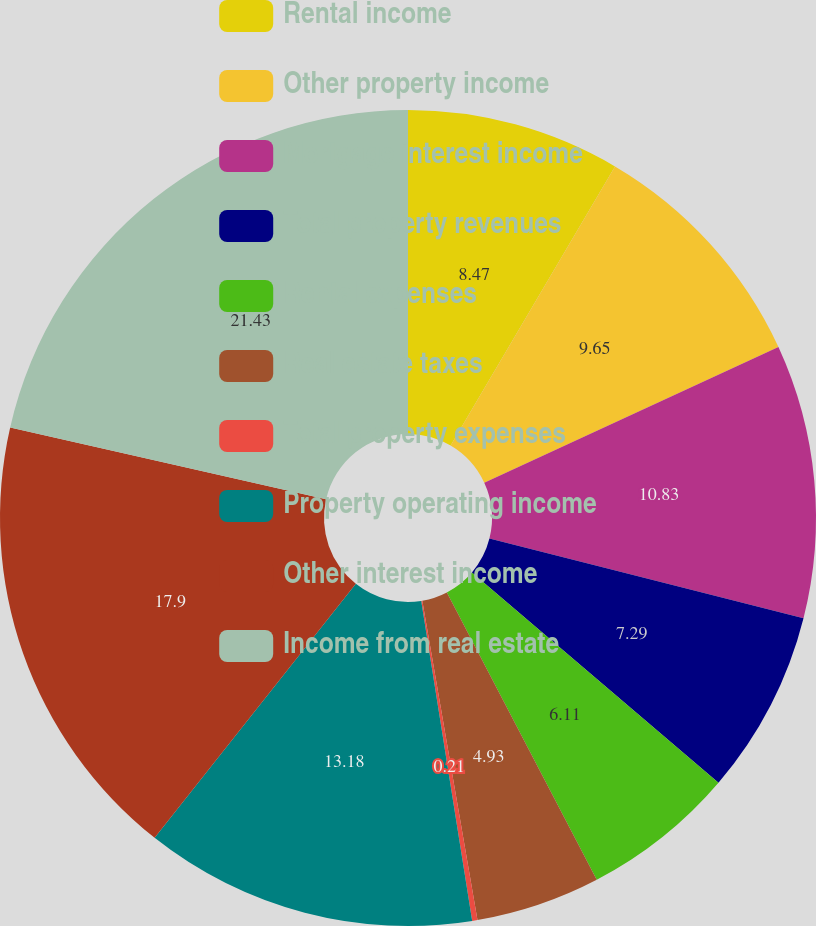<chart> <loc_0><loc_0><loc_500><loc_500><pie_chart><fcel>Rental income<fcel>Other property income<fcel>Mortgage interest income<fcel>Total property revenues<fcel>Rental expenses<fcel>Real estate taxes<fcel>Total property expenses<fcel>Property operating income<fcel>Other interest income<fcel>Income from real estate<nl><fcel>8.47%<fcel>9.65%<fcel>10.83%<fcel>7.29%<fcel>6.11%<fcel>4.93%<fcel>0.21%<fcel>13.18%<fcel>17.9%<fcel>21.44%<nl></chart> 